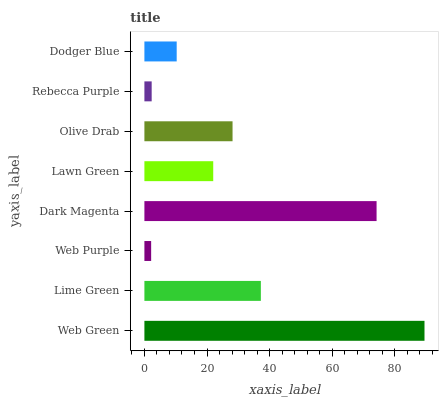Is Web Purple the minimum?
Answer yes or no. Yes. Is Web Green the maximum?
Answer yes or no. Yes. Is Lime Green the minimum?
Answer yes or no. No. Is Lime Green the maximum?
Answer yes or no. No. Is Web Green greater than Lime Green?
Answer yes or no. Yes. Is Lime Green less than Web Green?
Answer yes or no. Yes. Is Lime Green greater than Web Green?
Answer yes or no. No. Is Web Green less than Lime Green?
Answer yes or no. No. Is Olive Drab the high median?
Answer yes or no. Yes. Is Lawn Green the low median?
Answer yes or no. Yes. Is Web Purple the high median?
Answer yes or no. No. Is Olive Drab the low median?
Answer yes or no. No. 